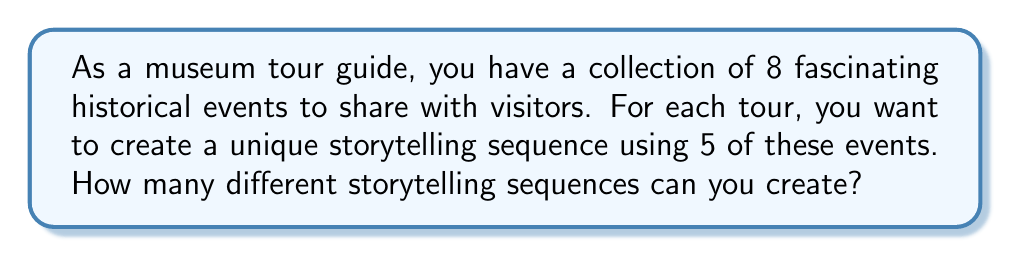What is the answer to this math problem? To solve this problem, we need to use the concept of permutations. Here's a step-by-step explanation:

1. We are selecting 5 events out of 8 and arranging them in a specific order. This is a permutation without repetition.

2. The formula for permutations without repetition is:

   $$P(n,r) = \frac{n!}{(n-r)!}$$

   Where $n$ is the total number of items to choose from, and $r$ is the number of items being chosen and arranged.

3. In this case, $n = 8$ (total historical events) and $r = 5$ (events used in each sequence).

4. Let's substitute these values into the formula:

   $$P(8,5) = \frac{8!}{(8-5)!} = \frac{8!}{3!}$$

5. Expand this:
   $$\frac{8 \times 7 \times 6 \times 5 \times 4 \times 3!}{3!}$$

6. The $3!$ cancels out in the numerator and denominator:
   $$8 \times 7 \times 6 \times 5 \times 4 = 6720$$

Therefore, you can create 6720 different storytelling sequences using 5 events from your collection of 8 historical events.
Answer: 6720 unique storytelling sequences 